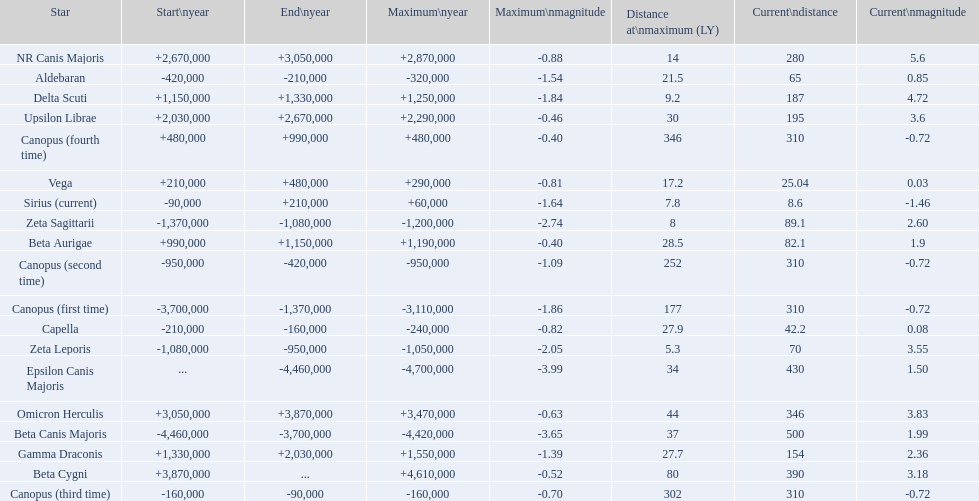Could you parse the entire table as a dict? {'header': ['Star', 'Start\\nyear', 'End\\nyear', 'Maximum\\nyear', 'Maximum\\nmagnitude', 'Distance at\\nmaximum (LY)', 'Current\\ndistance', 'Current\\nmagnitude'], 'rows': [['NR Canis Majoris', '+2,670,000', '+3,050,000', '+2,870,000', '-0.88', '14', '280', '5.6'], ['Aldebaran', '-420,000', '-210,000', '-320,000', '-1.54', '21.5', '65', '0.85'], ['Delta Scuti', '+1,150,000', '+1,330,000', '+1,250,000', '-1.84', '9.2', '187', '4.72'], ['Upsilon Librae', '+2,030,000', '+2,670,000', '+2,290,000', '-0.46', '30', '195', '3.6'], ['Canopus (fourth time)', '+480,000', '+990,000', '+480,000', '-0.40', '346', '310', '-0.72'], ['Vega', '+210,000', '+480,000', '+290,000', '-0.81', '17.2', '25.04', '0.03'], ['Sirius (current)', '-90,000', '+210,000', '+60,000', '-1.64', '7.8', '8.6', '-1.46'], ['Zeta Sagittarii', '-1,370,000', '-1,080,000', '-1,200,000', '-2.74', '8', '89.1', '2.60'], ['Beta Aurigae', '+990,000', '+1,150,000', '+1,190,000', '-0.40', '28.5', '82.1', '1.9'], ['Canopus (second time)', '-950,000', '-420,000', '-950,000', '-1.09', '252', '310', '-0.72'], ['Canopus (first time)', '-3,700,000', '-1,370,000', '-3,110,000', '-1.86', '177', '310', '-0.72'], ['Capella', '-210,000', '-160,000', '-240,000', '-0.82', '27.9', '42.2', '0.08'], ['Zeta Leporis', '-1,080,000', '-950,000', '-1,050,000', '-2.05', '5.3', '70', '3.55'], ['Epsilon Canis Majoris', '...', '-4,460,000', '-4,700,000', '-3.99', '34', '430', '1.50'], ['Omicron Herculis', '+3,050,000', '+3,870,000', '+3,470,000', '-0.63', '44', '346', '3.83'], ['Beta Canis Majoris', '-4,460,000', '-3,700,000', '-4,420,000', '-3.65', '37', '500', '1.99'], ['Gamma Draconis', '+1,330,000', '+2,030,000', '+1,550,000', '-1.39', '27.7', '154', '2.36'], ['Beta Cygni', '+3,870,000', '...', '+4,610,000', '-0.52', '80', '390', '3.18'], ['Canopus (third time)', '-160,000', '-90,000', '-160,000', '-0.70', '302', '310', '-0.72']]} Which star has the highest distance at maximum? Canopus (fourth time). 